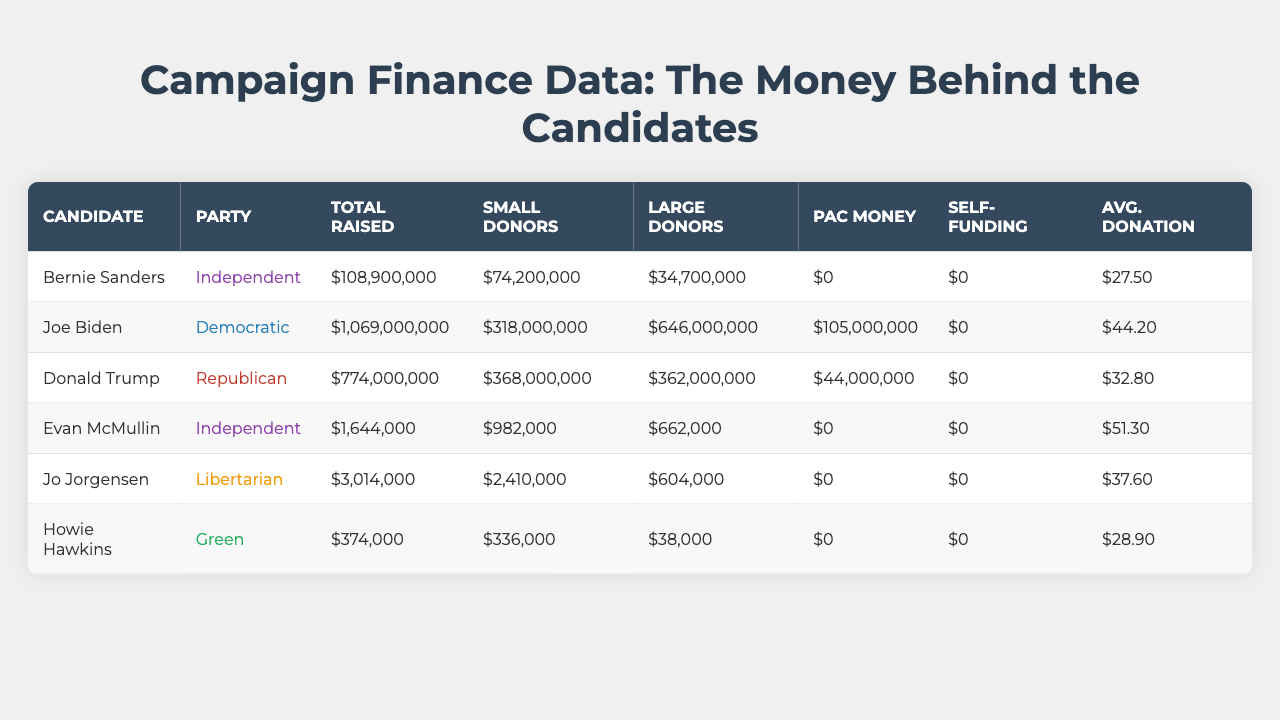What is the total amount raised by Bernie Sanders? The total raised by Bernie Sanders is listed in the table under "Total Raised," which shows $108,900,000.
Answer: $108,900,000 Which candidate has the highest number of small donors? By checking the "Small Donors" column, Joe Biden has the highest number of small donors with $318,000,000.
Answer: Joe Biden Is there any candidate who received PAC money? The "PAC Money" column indicates that both Joe Biden and Donald Trump received PAC money, while independent candidates received none.
Answer: Yes What is the average donation amount for candidates from major parties? The average donation amount can be calculated by taking Joe Biden's ($44.20) and Donald Trump's ($32.80) and averaging them: (44.20 + 32.80) / 2 = 38.50.
Answer: $38.50 How much more total money did Joe Biden raise compared to Evan McMullin? Joe Biden raised $1,069,000,000, while Evan McMullin raised $1,644,000. The difference is $1,069,000,000 - $1,644,000 = $1,067,356,000.
Answer: $1,067,356,000 Which party raised the least amount of money overall? Evaluating the total raised by each party, the Green party's Howie Hawkins raised only $374,000, which is the least compared to other candidates.
Answer: Green party What percentage of total funds raised by Donald Trump came from large donors? Donald Trump raised a total of $774,000,000 with $362,000,000 coming from large donors. The percentage is calculated as (362,000,000 / 774,000,000) * 100 = 46.7%.
Answer: 46.7% How much was raised by independent candidates in total? Adding the totals for independent candidates: Bernie Sanders ($108,900,000) + Evan McMullin ($1,644,000) = $110,544,000.
Answer: $110,544,000 Is the average donation among small donors higher for independent candidates compared to major party candidates? The average donation for small donors in this table is $27.50 for Bernie Sanders and $44.20 for Joe Biden and $32.80 for Donald Trump. The average for major party candidates is higher.
Answer: No What is the total amount raised from small donors by all candidates? To find this, we sum the small donor amounts: $74,200,000 (Sanders) + $318,000,000 (Biden) + $368,000,000 (Trump) + $982,000 (McMullin) + $2,410,000 (Jorgensen) + $336,000 (Hawkins) = $763,116,000.
Answer: $763,116,000 